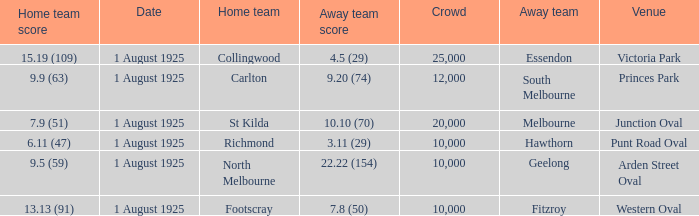Which team plays home at Princes Park? Carlton. 